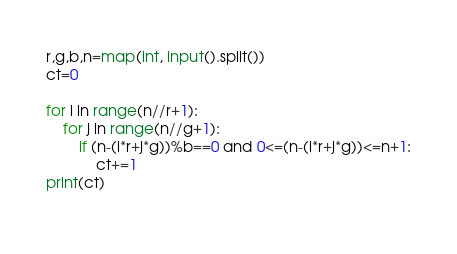<code> <loc_0><loc_0><loc_500><loc_500><_Python_>r,g,b,n=map(int, input().split())
ct=0

for i in range(n//r+1):
    for j in range(n//g+1):
        if (n-(i*r+j*g))%b==0 and 0<=(n-(i*r+j*g))<=n+1:
            ct+=1
print(ct)
    </code> 